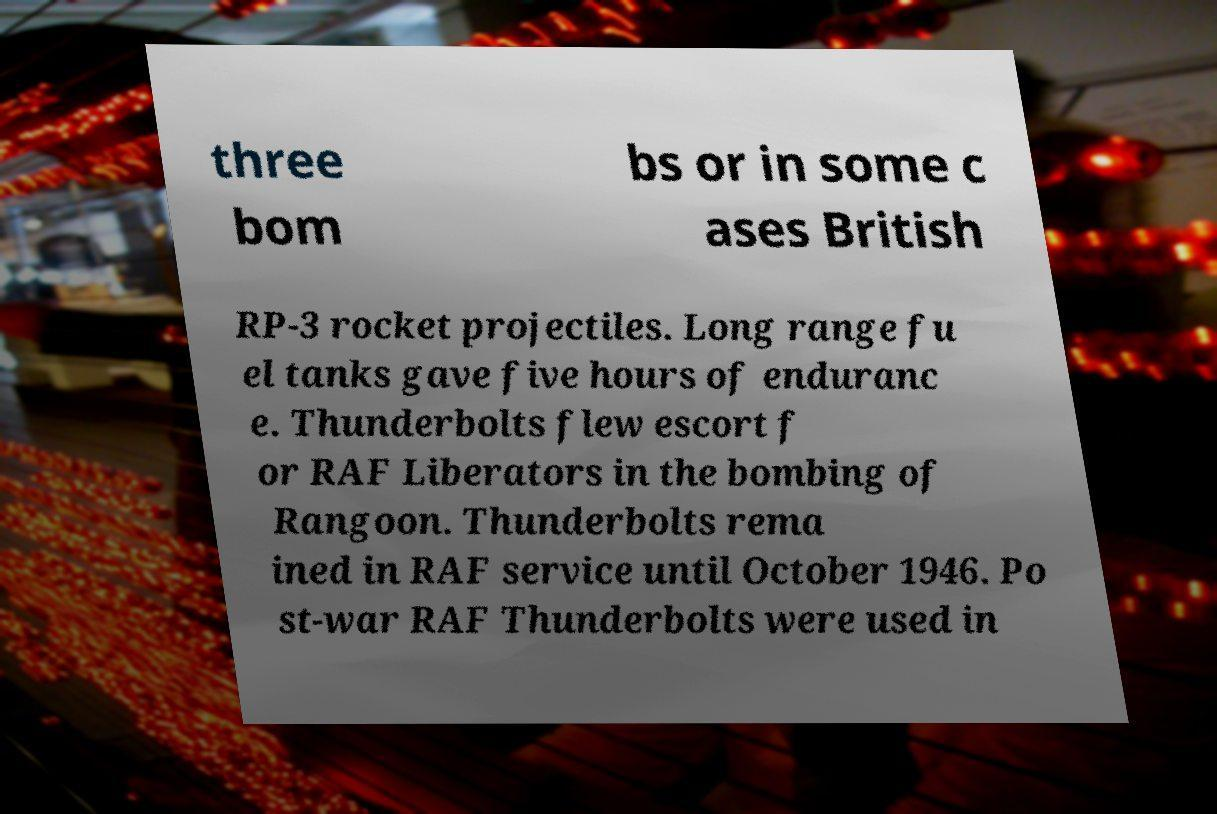For documentation purposes, I need the text within this image transcribed. Could you provide that? three bom bs or in some c ases British RP-3 rocket projectiles. Long range fu el tanks gave five hours of enduranc e. Thunderbolts flew escort f or RAF Liberators in the bombing of Rangoon. Thunderbolts rema ined in RAF service until October 1946. Po st-war RAF Thunderbolts were used in 